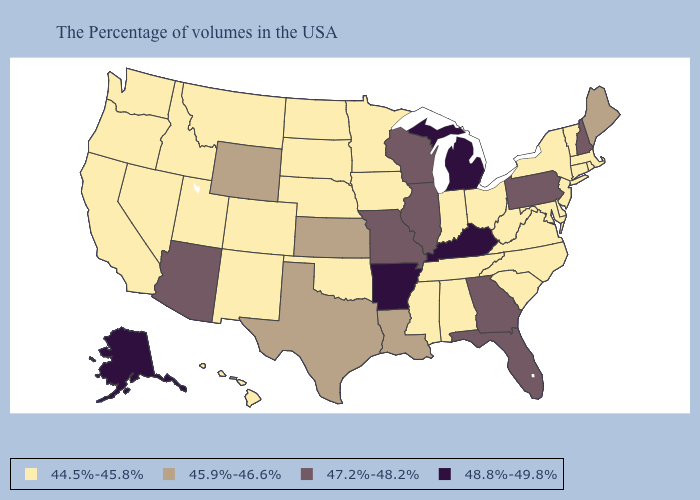What is the lowest value in states that border Washington?
Keep it brief. 44.5%-45.8%. Among the states that border Colorado , does Nebraska have the highest value?
Short answer required. No. What is the lowest value in the MidWest?
Short answer required. 44.5%-45.8%. Does the first symbol in the legend represent the smallest category?
Write a very short answer. Yes. What is the value of Georgia?
Keep it brief. 47.2%-48.2%. Does California have the lowest value in the West?
Give a very brief answer. Yes. Which states have the lowest value in the USA?
Answer briefly. Massachusetts, Rhode Island, Vermont, Connecticut, New York, New Jersey, Delaware, Maryland, Virginia, North Carolina, South Carolina, West Virginia, Ohio, Indiana, Alabama, Tennessee, Mississippi, Minnesota, Iowa, Nebraska, Oklahoma, South Dakota, North Dakota, Colorado, New Mexico, Utah, Montana, Idaho, Nevada, California, Washington, Oregon, Hawaii. Which states have the lowest value in the USA?
Be succinct. Massachusetts, Rhode Island, Vermont, Connecticut, New York, New Jersey, Delaware, Maryland, Virginia, North Carolina, South Carolina, West Virginia, Ohio, Indiana, Alabama, Tennessee, Mississippi, Minnesota, Iowa, Nebraska, Oklahoma, South Dakota, North Dakota, Colorado, New Mexico, Utah, Montana, Idaho, Nevada, California, Washington, Oregon, Hawaii. Does the map have missing data?
Concise answer only. No. How many symbols are there in the legend?
Concise answer only. 4. What is the value of Montana?
Concise answer only. 44.5%-45.8%. Name the states that have a value in the range 44.5%-45.8%?
Concise answer only. Massachusetts, Rhode Island, Vermont, Connecticut, New York, New Jersey, Delaware, Maryland, Virginia, North Carolina, South Carolina, West Virginia, Ohio, Indiana, Alabama, Tennessee, Mississippi, Minnesota, Iowa, Nebraska, Oklahoma, South Dakota, North Dakota, Colorado, New Mexico, Utah, Montana, Idaho, Nevada, California, Washington, Oregon, Hawaii. Name the states that have a value in the range 45.9%-46.6%?
Concise answer only. Maine, Louisiana, Kansas, Texas, Wyoming. Name the states that have a value in the range 48.8%-49.8%?
Be succinct. Michigan, Kentucky, Arkansas, Alaska. 